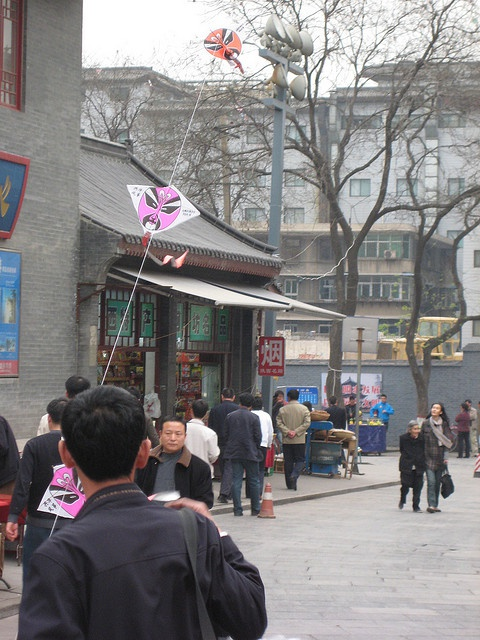Describe the objects in this image and their specific colors. I can see people in gray and black tones, people in gray, black, and brown tones, people in gray, black, darkgray, and maroon tones, people in gray, black, and salmon tones, and people in gray, black, and darkblue tones in this image. 